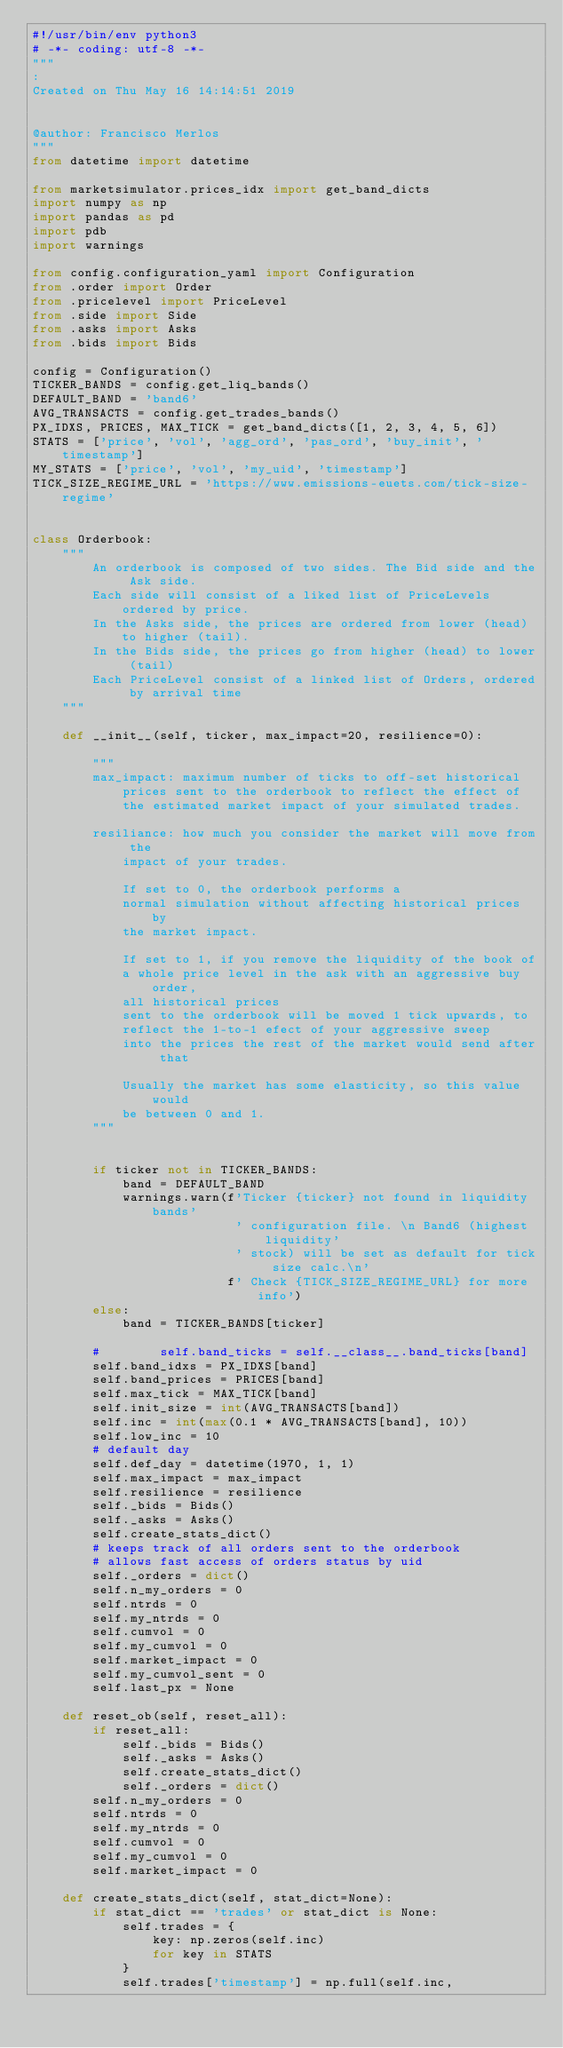<code> <loc_0><loc_0><loc_500><loc_500><_Python_>#!/usr/bin/env python3
# -*- coding: utf-8 -*-
"""
:
Created on Thu May 16 14:14:51 2019


@author: Francisco Merlos
"""
from datetime import datetime

from marketsimulator.prices_idx import get_band_dicts
import numpy as np
import pandas as pd
import pdb
import warnings

from config.configuration_yaml import Configuration
from .order import Order
from .pricelevel import PriceLevel
from .side import Side
from .asks import Asks
from .bids import Bids

config = Configuration()
TICKER_BANDS = config.get_liq_bands()
DEFAULT_BAND = 'band6'
AVG_TRANSACTS = config.get_trades_bands()
PX_IDXS, PRICES, MAX_TICK = get_band_dicts([1, 2, 3, 4, 5, 6])
STATS = ['price', 'vol', 'agg_ord', 'pas_ord', 'buy_init', 'timestamp']
MY_STATS = ['price', 'vol', 'my_uid', 'timestamp']
TICK_SIZE_REGIME_URL = 'https://www.emissions-euets.com/tick-size-regime'


class Orderbook:
    """ 
        An orderbook is composed of two sides. The Bid side and the Ask side.
        Each side will consist of a liked list of PriceLevels ordered by price.
        In the Asks side, the prices are ordered from lower (head) to higher (tail).
        In the Bids side, the prices go from higher (head) to lower (tail)
        Each PriceLevel consist of a linked list of Orders, ordered by arrival time
    """

    def __init__(self, ticker, max_impact=20, resilience=0):

        """        
        max_impact: maximum number of ticks to off-set historical 
            prices sent to the orderbook to reflect the effect of 
            the estimated market impact of your simulated trades.
        
        resiliance: how much you consider the market will move from the
            impact of your trades. 
            
            If set to 0, the orderbook performs a
            normal simulation without affecting historical prices by 
            the market impact.

            If set to 1, if you remove the liquidity of the book of
            a whole price level in the ask with an aggressive buy order,
            all historical prices 
            sent to the orderbook will be moved 1 tick upwards, to 
            reflect the 1-to-1 efect of your aggressive sweep
            into the prices the rest of the market would send after that
            
            Usually the market has some elasticity, so this value would
            be between 0 and 1. 
        """


        if ticker not in TICKER_BANDS:
            band = DEFAULT_BAND
            warnings.warn(f'Ticker {ticker} not found in liquidity bands'
                           ' configuration file. \n Band6 (highest liquidity'
                           ' stock) will be set as default for tick size calc.\n'
                          f' Check {TICK_SIZE_REGIME_URL} for more info')
        else:
            band = TICKER_BANDS[ticker]
            
        #        self.band_ticks = self.__class__.band_ticks[band]
        self.band_idxs = PX_IDXS[band]
        self.band_prices = PRICES[band]
        self.max_tick = MAX_TICK[band]
        self.init_size = int(AVG_TRANSACTS[band])
        self.inc = int(max(0.1 * AVG_TRANSACTS[band], 10))
        self.low_inc = 10
        # default day
        self.def_day = datetime(1970, 1, 1)
        self.max_impact = max_impact
        self.resilience = resilience
        self._bids = Bids()
        self._asks = Asks()
        self.create_stats_dict()
        # keeps track of all orders sent to the orderbook
        # allows fast access of orders status by uid
        self._orders = dict()
        self.n_my_orders = 0
        self.ntrds = 0
        self.my_ntrds = 0
        self.cumvol = 0
        self.my_cumvol = 0
        self.market_impact = 0
        self.my_cumvol_sent = 0
        self.last_px = None

    def reset_ob(self, reset_all):
        if reset_all:
            self._bids = Bids()
            self._asks = Asks()
            self.create_stats_dict()
            self._orders = dict()
        self.n_my_orders = 0
        self.ntrds = 0
        self.my_ntrds = 0
        self.cumvol = 0
        self.my_cumvol = 0
        self.market_impact = 0

    def create_stats_dict(self, stat_dict=None):
        if stat_dict == 'trades' or stat_dict is None:
            self.trades = {
                key: np.zeros(self.inc)
                for key in STATS
            }
            self.trades['timestamp'] = np.full(self.inc,</code> 